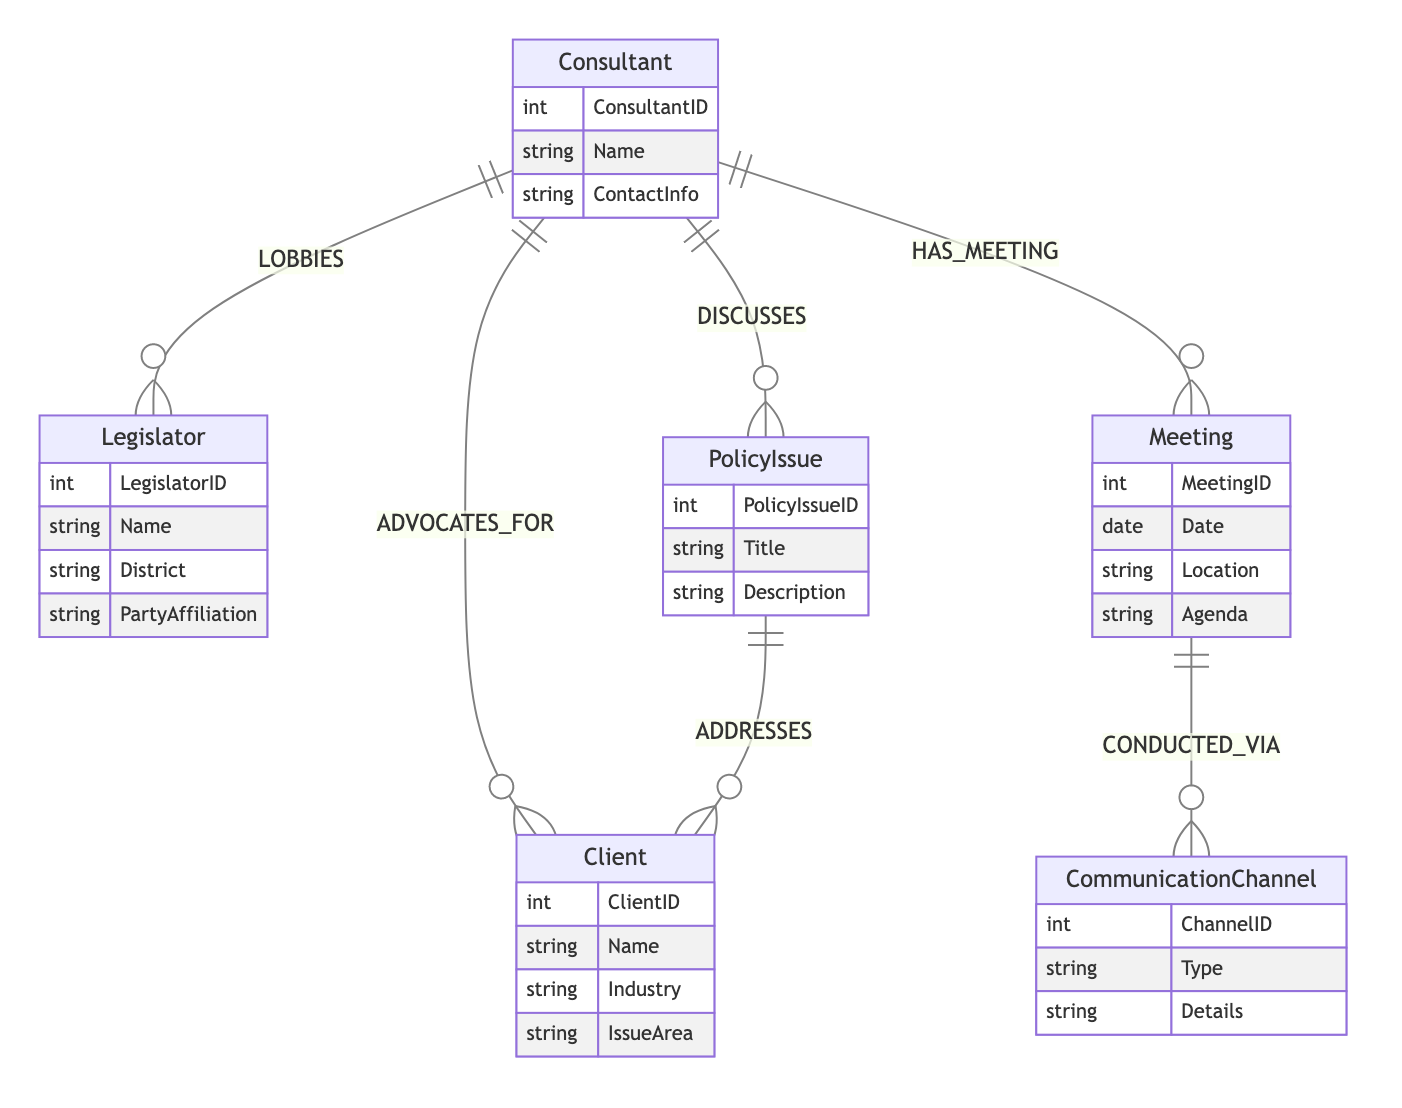What are the entities represented in the diagram? The diagram includes six entities: Consultant, Client, Legislator, PolicyIssue, Meeting, and CommunicationChannel. Each entity is listed within the diagram boundaries, representing key components of the policy advocacy process.
Answer: Consultant, Client, Legislator, PolicyIssue, Meeting, CommunicationChannel How many relationships are depicted in the diagram? There are five relationships shown in the diagram: ADVOCATES_FOR, LOBBIES, DISCUSSES, HAS_MEETING, and CONDUCTED_VIA. Each relationship connects the entities to illustrate interactions within the advocacy process.
Answer: Five What does the relationship 'ADVOCATES_FOR' connect? The relationship 'ADVOCATES_FOR' connects the Consultant to the Client, indicating that the Consultant advocates on behalf of the Client's interests.
Answer: Consultant to Client Which entity conducts meetings? The Meeting entity represents the meetings that are organized and conducted involving the Consultant. This entity is central to the meeting aspect of policy advocacy.
Answer: Meeting What is the purpose of the relationship 'ADDRESSES'? The relationship 'ADDRESSES' involves the PolicyIssue addressing a Client's concerns or interests, indicating that specific policy issues are significant to the clients represented.
Answer: PolicyIssue to Client How is a meeting conducted according to the diagram? A meeting is conducted via a CommunicationChannel, which specifies the means or method used for facilitating the meeting. The relationship clearly connects the Meeting entity to the CommunicationChannel entity.
Answer: CommunicationChannel Which entity is directly connected to the Legislator? The Legislator entity is connected to the Consultant via the LOBBIES relationship, illustrating the direct lobbying efforts of the Consultant towards the Legislator.
Answer: Consultant What type of information does the CommunicationChannel hold? The CommunicationChannel holds attributes such as Type and Details, which inform about the method of communication used during meetings. These attributes allow for detailed descriptions of how communications are handled.
Answer: Type, Details Which entity discusses Policy Issues? The Consultant entity is responsible for discussing PolicyIssues, showing that consultants engage in conversations or discussions regarding specific policy matters.
Answer: Consultant 